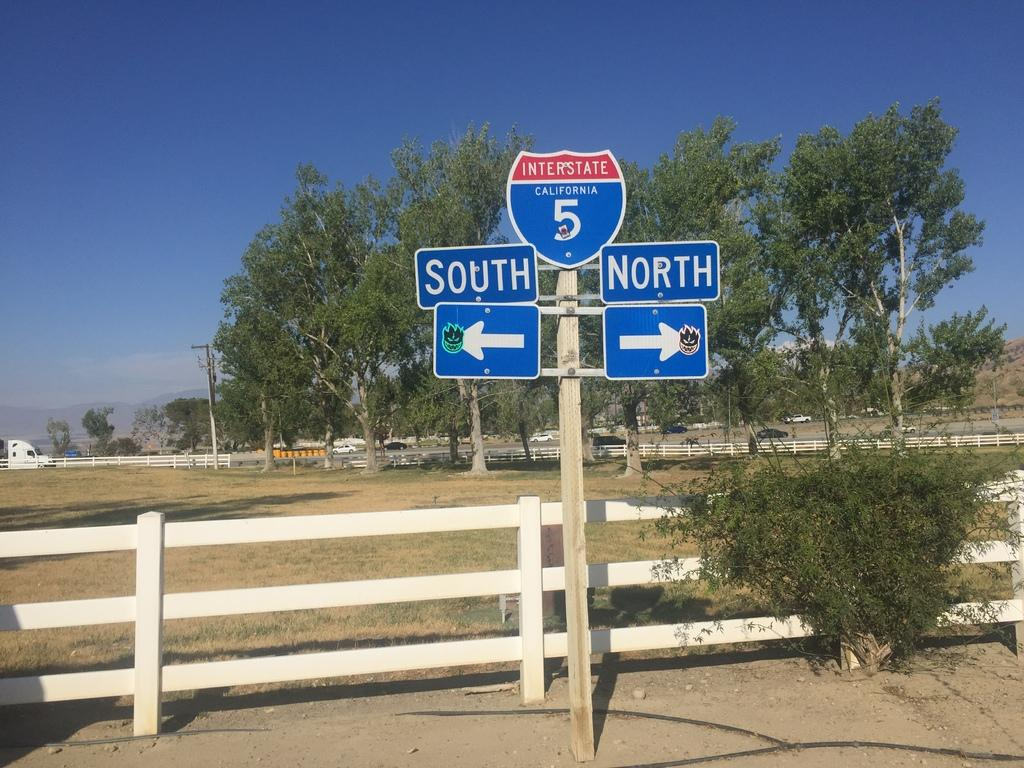<image>
Share a concise interpretation of the image provided. the number 5 on a blue sign pointing south and north 